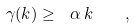<formula> <loc_0><loc_0><loc_500><loc_500>\gamma ( k ) \geq \ \alpha \, k \quad ,</formula> 